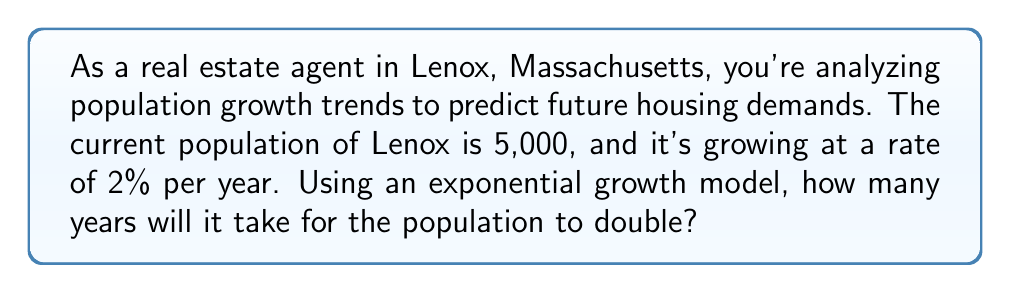Solve this math problem. Let's approach this step-by-step using an exponential growth model and logarithms:

1) The exponential growth model is given by:
   $$ P(t) = P_0 \cdot e^{rt} $$
   where $P(t)$ is the population at time $t$, $P_0$ is the initial population, $r$ is the growth rate, and $t$ is time in years.

2) We want to find $t$ when the population doubles, so:
   $$ 2P_0 = P_0 \cdot e^{rt} $$

3) Simplify by dividing both sides by $P_0$:
   $$ 2 = e^{rt} $$

4) Take the natural logarithm of both sides:
   $$ \ln(2) = \ln(e^{rt}) $$

5) Simplify the right side using logarithm properties:
   $$ \ln(2) = rt $$

6) Solve for $t$:
   $$ t = \frac{\ln(2)}{r} $$

7) We know $r = 0.02$ (2% expressed as a decimal), so:
   $$ t = \frac{\ln(2)}{0.02} $$

8) Calculate:
   $$ t = \frac{0.693147...}{0.02} \approx 34.66 \text{ years} $$

Therefore, it will take approximately 34.66 years for the population to double.
Answer: 34.66 years 